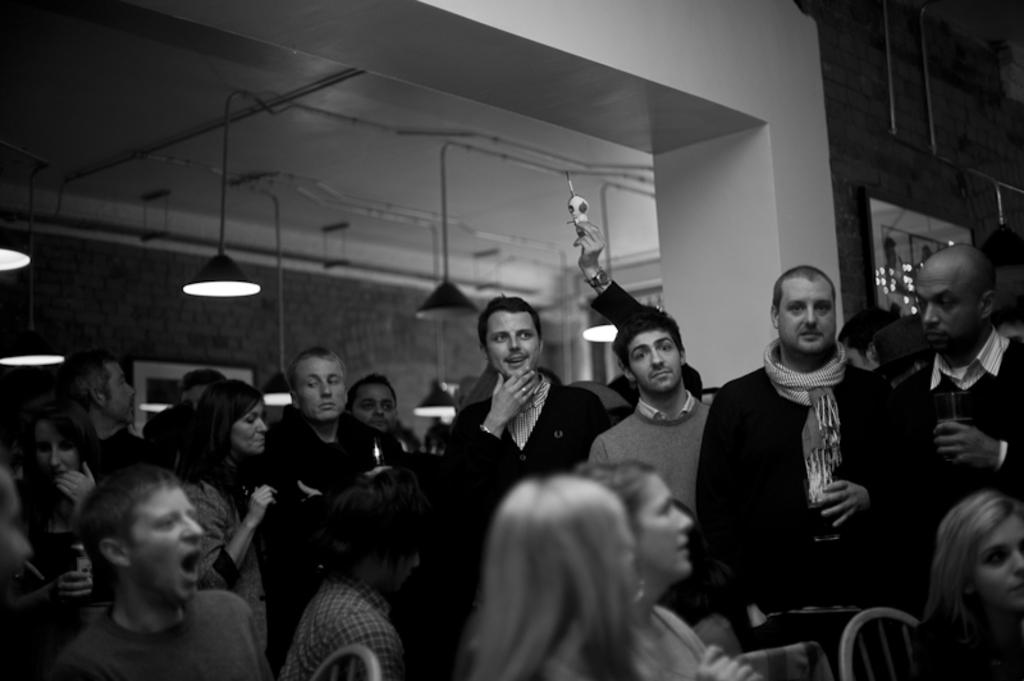What is the color scheme of the image? The image is black and white. What can be seen inside the room? There are people in the room. What is on the wall in the room? There is a wall with a photo frame in the room. What type of lighting is present in the room? There are lights attached to the ceiling. What advice does the grandmother give in the image? There is no grandmother present in the image, so no advice can be given. What type of club is visible in the image? There is no club present in the image. 